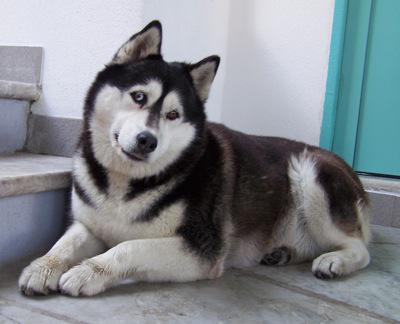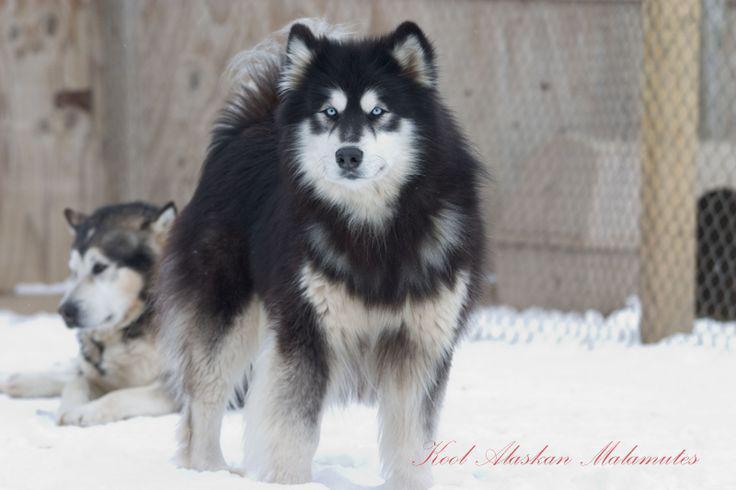The first image is the image on the left, the second image is the image on the right. Assess this claim about the two images: "The left image shows a smaller black-and-tan spaniel sitting to the left of a taller black-and-white sitting husky with open mouth and upright ears.". Correct or not? Answer yes or no. No. The first image is the image on the left, the second image is the image on the right. Evaluate the accuracy of this statement regarding the images: "In one image, at least one dog has its mouth open, and in the other image, no dogs have their mouth open.". Is it true? Answer yes or no. No. 